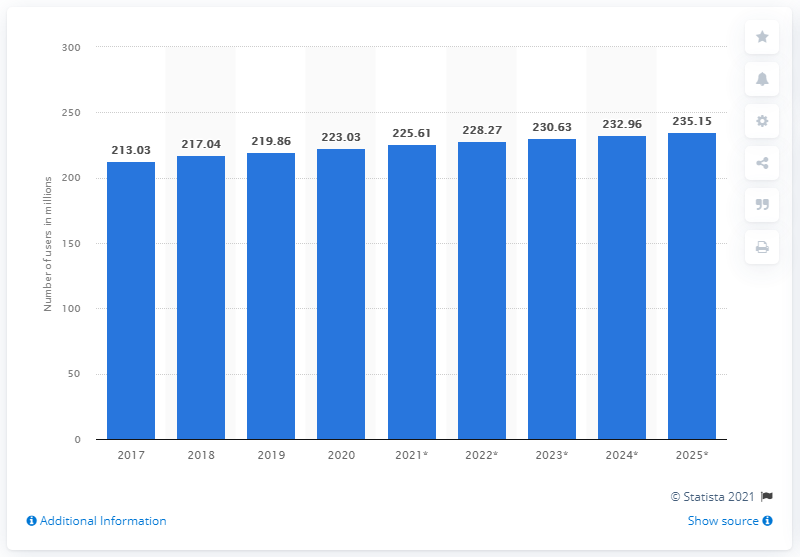Highlight a few significant elements in this photo. In 2020, there were approximately 223.03 million Facebook users in the United States. The estimated population of Facebook users in the United States in 2025 is approximately 235.15 million people. 